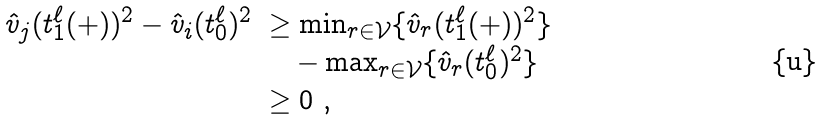Convert formula to latex. <formula><loc_0><loc_0><loc_500><loc_500>\begin{array} { l l l l } \hat { v } _ { j } ( t ^ { \ell } _ { 1 } ( + ) ) ^ { 2 } - \hat { v } _ { i } ( t ^ { \ell } _ { 0 } ) ^ { 2 } & \geq \min _ { r \in \mathcal { V } } \{ \hat { v } _ { r } ( t ^ { \ell } _ { 1 } ( + ) ) ^ { 2 } \} \\ & \quad - \max _ { r \in \mathcal { V } } \{ \hat { v } _ { r } ( t ^ { \ell } _ { 0 } ) ^ { 2 } \} \\ & \geq 0 \ , \end{array}</formula> 